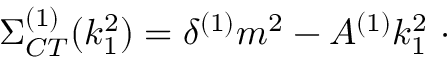Convert formula to latex. <formula><loc_0><loc_0><loc_500><loc_500>\Sigma _ { C T } ^ { ( 1 ) } ( k _ { 1 } ^ { 2 } ) = \delta ^ { ( 1 ) } m ^ { 2 } - A ^ { ( 1 ) } k _ { 1 } ^ { 2 } \ \cdot</formula> 